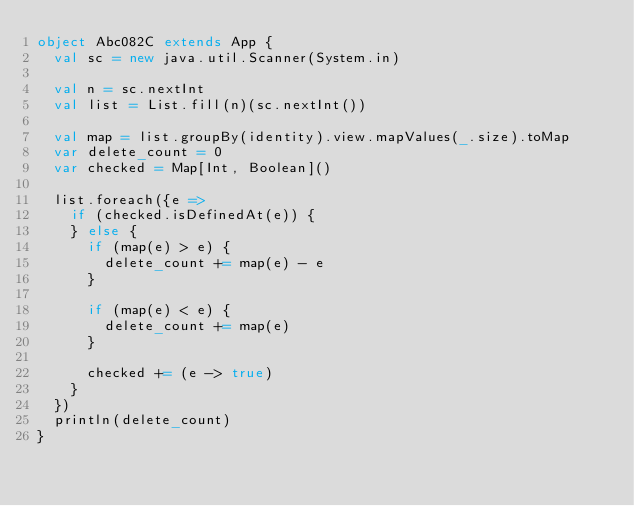<code> <loc_0><loc_0><loc_500><loc_500><_Scala_>object Abc082C extends App {
  val sc = new java.util.Scanner(System.in)

  val n = sc.nextInt
  val list = List.fill(n)(sc.nextInt())

  val map = list.groupBy(identity).view.mapValues(_.size).toMap
  var delete_count = 0
  var checked = Map[Int, Boolean]()

  list.foreach({e =>
    if (checked.isDefinedAt(e)) {
    } else {
      if (map(e) > e) {
        delete_count += map(e) - e
      }

      if (map(e) < e) {
        delete_count += map(e)
      }

      checked += (e -> true)
    }
  })
  println(delete_count)
}
</code> 